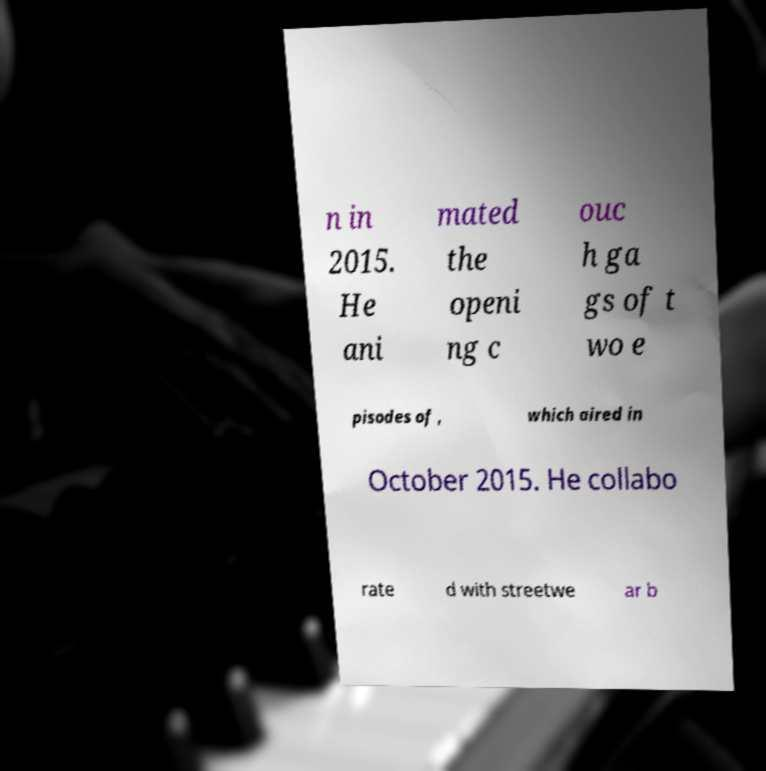Could you assist in decoding the text presented in this image and type it out clearly? n in 2015. He ani mated the openi ng c ouc h ga gs of t wo e pisodes of , which aired in October 2015. He collabo rate d with streetwe ar b 